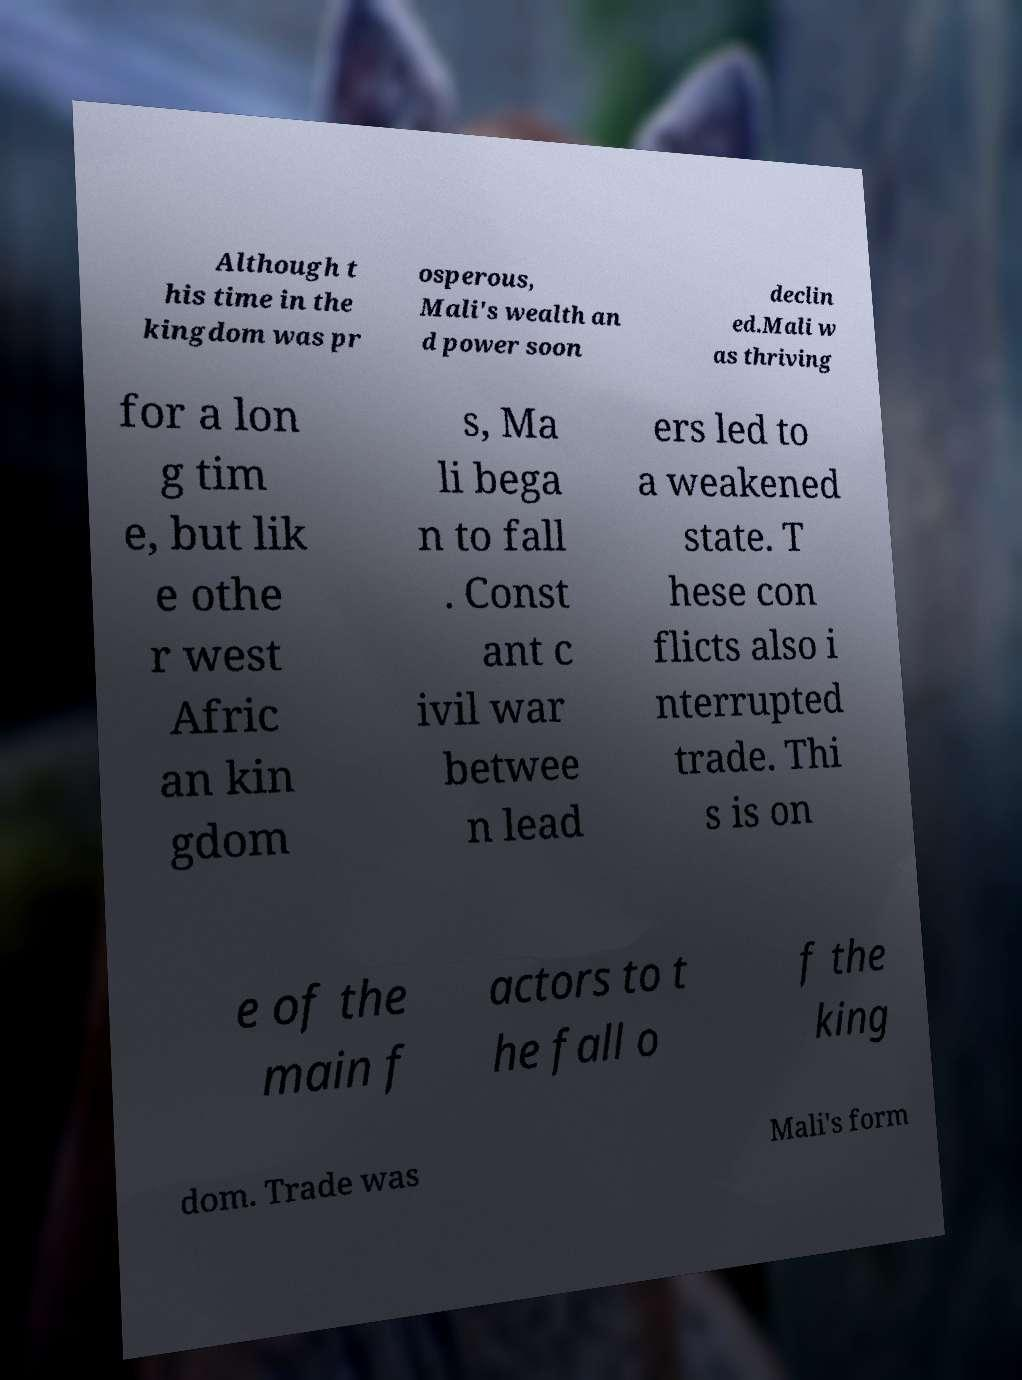Can you accurately transcribe the text from the provided image for me? Although t his time in the kingdom was pr osperous, Mali's wealth an d power soon declin ed.Mali w as thriving for a lon g tim e, but lik e othe r west Afric an kin gdom s, Ma li bega n to fall . Const ant c ivil war betwee n lead ers led to a weakened state. T hese con flicts also i nterrupted trade. Thi s is on e of the main f actors to t he fall o f the king dom. Trade was Mali's form 